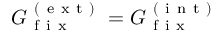<formula> <loc_0><loc_0><loc_500><loc_500>G _ { f i x } ^ { ( e x t ) } = G _ { f i x } ^ { ( i n t ) }</formula> 